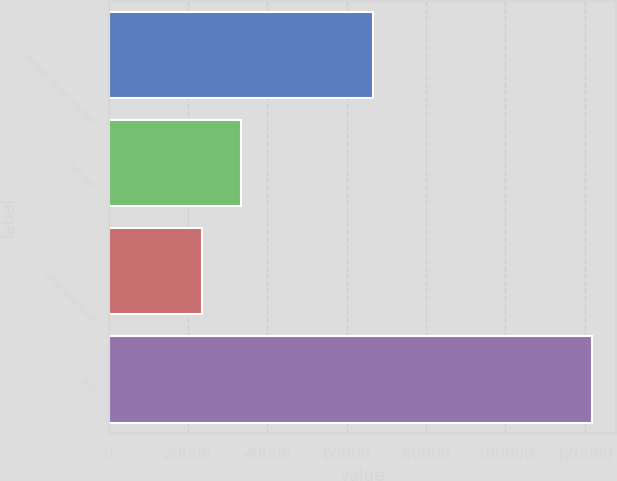<chart> <loc_0><loc_0><loc_500><loc_500><bar_chart><fcel>Mortgage-backed securities<fcel>Corporate<fcel>Foreign government<fcel>Total<nl><fcel>66658<fcel>33426.7<fcel>23603<fcel>121840<nl></chart> 